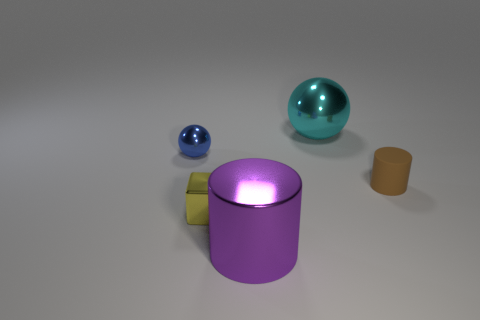Is the tiny blue ball made of the same material as the small block? Although they both have shiny surfaces that suggest they could be made of similar materials, without more context or information, it's challenging to determine with certainty if the tiny blue ball is made from the exact same material as the small block. Such determination often requires a closer inspection or knowledge about the objects' composition. 